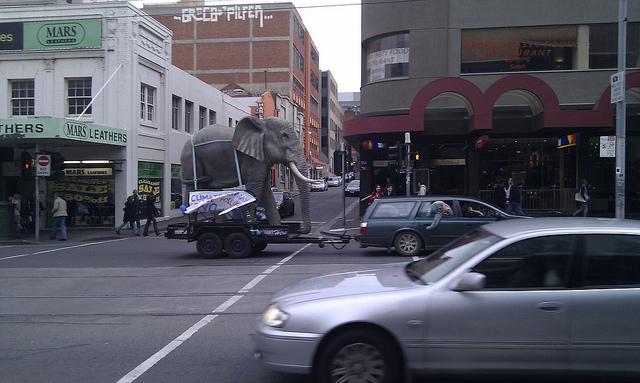How many vehicles do you see?
Keep it brief. 2. What color is the closest car in the picture?
Concise answer only. Silver. What type of building is shown?
Give a very brief answer. Store. What restaurant is closest on the right?
Be succinct. None. Is the elephant alive?
Be succinct. No. 